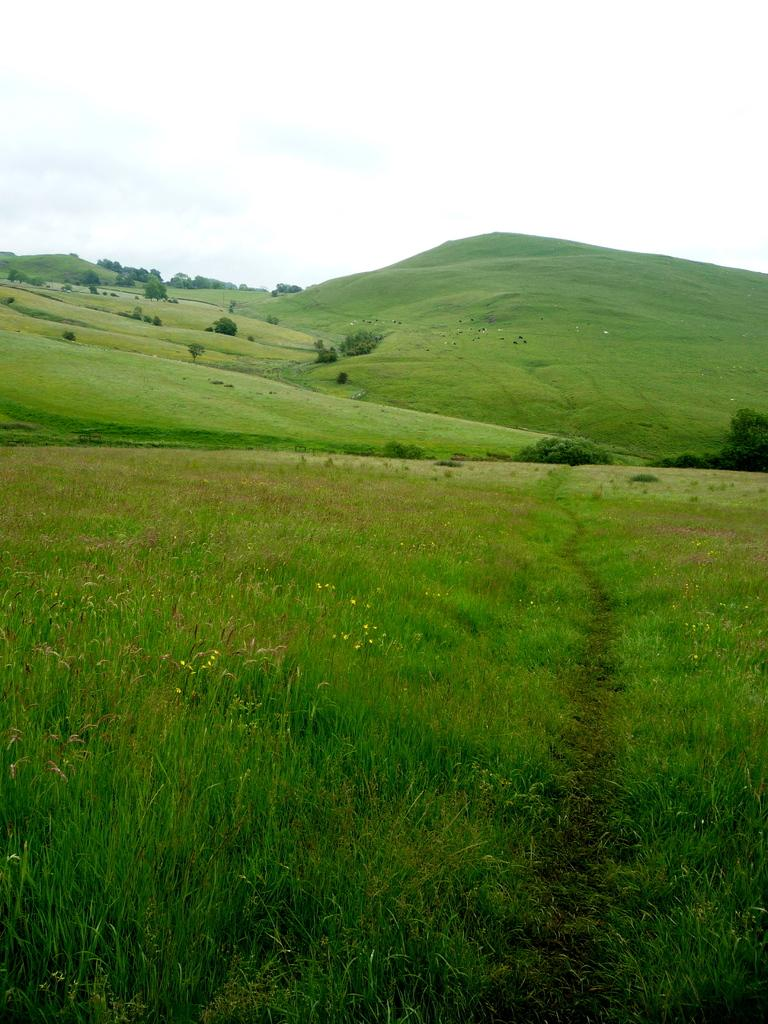What types of vegetation can be seen in the image? There are plants and flowers in the image. What type of ground cover is visible in the background of the image? There is grass in the background of the image. What other types of vegetation are present in the background of the image? There are plants and trees in the background of the image. What is visible at the top of the image? The sky is visible at the top of the image. What type of trousers are hanging on the rod in the image? There is no rod or trousers present in the image; it features plants, flowers, grass, and trees. 